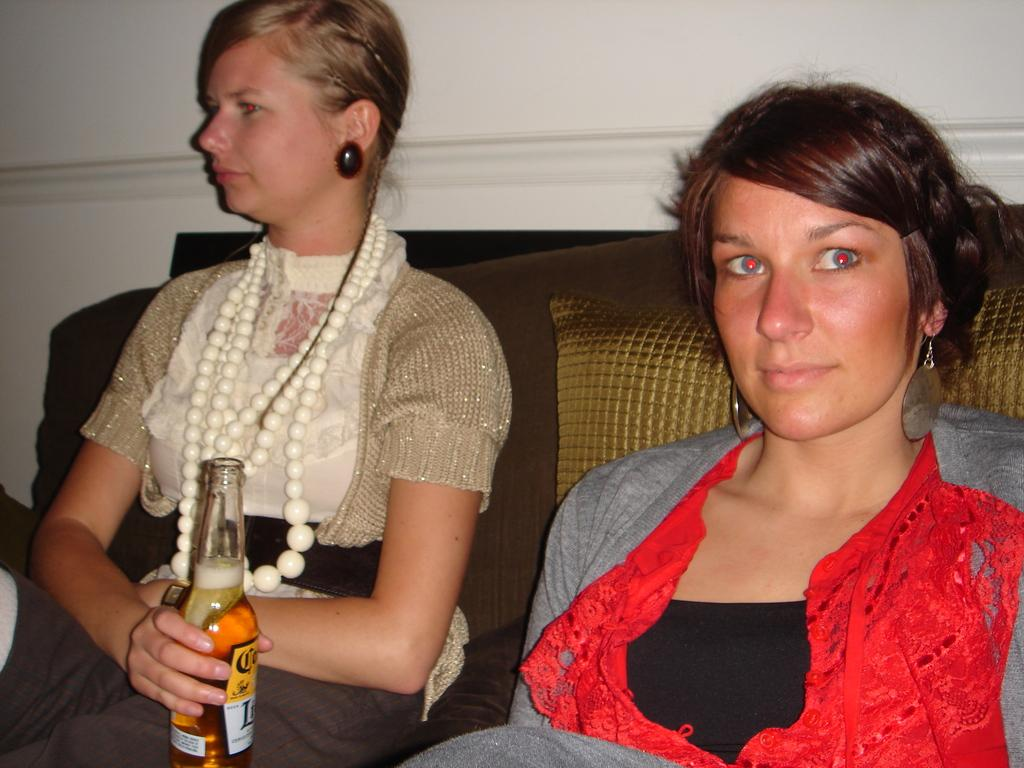How many people are in the image? There are two women in the image. What are the women doing in the image? The women are sitting on a couch. What is the woman on the left holding? The woman on the left is holding a bottle. What type of prose is being read by the women in the image? There is no indication in the image that the women are reading any prose. 